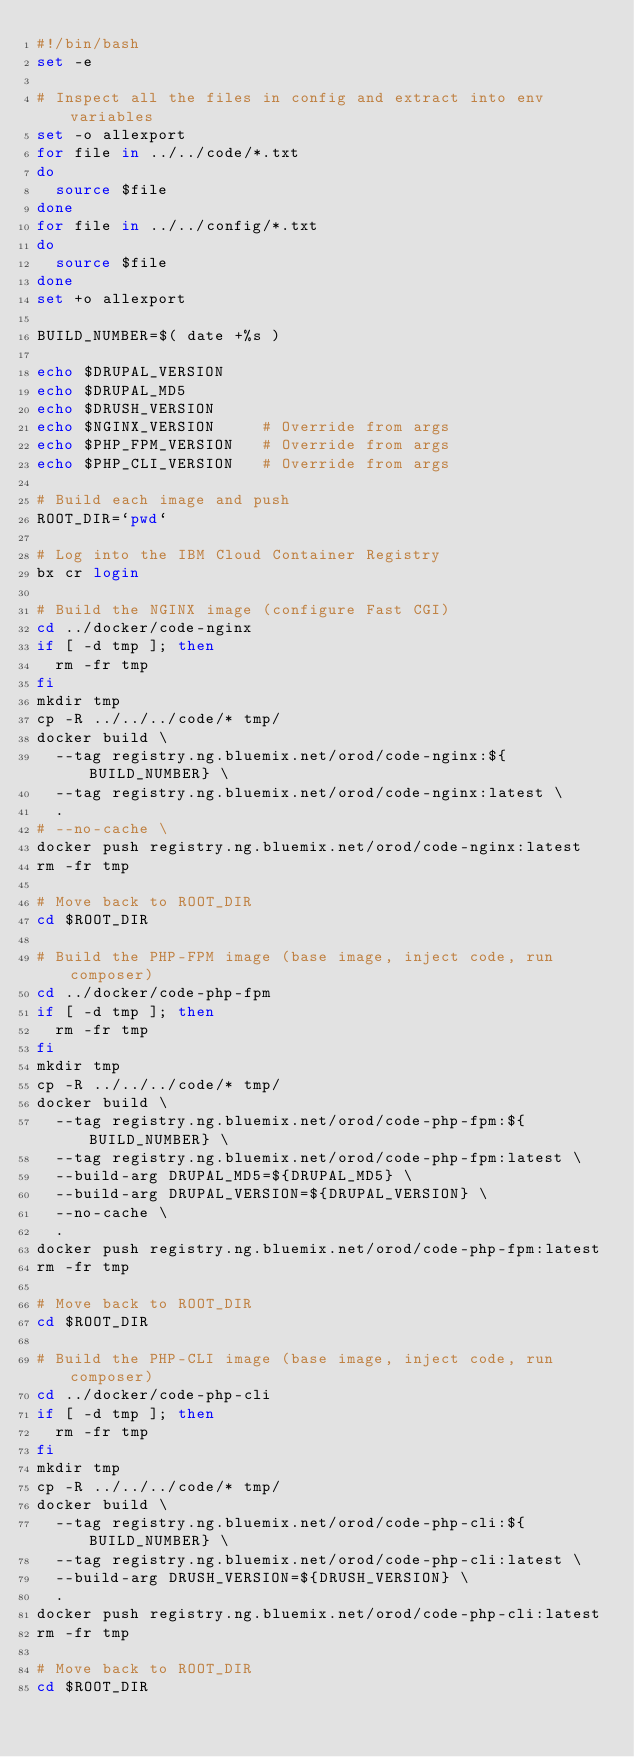Convert code to text. <code><loc_0><loc_0><loc_500><loc_500><_Bash_>#!/bin/bash
set -e

# Inspect all the files in config and extract into env variables
set -o allexport
for file in ../../code/*.txt
do
  source $file
done
for file in ../../config/*.txt
do
  source $file
done
set +o allexport

BUILD_NUMBER=$( date +%s )

echo $DRUPAL_VERSION
echo $DRUPAL_MD5
echo $DRUSH_VERSION
echo $NGINX_VERSION     # Override from args
echo $PHP_FPM_VERSION   # Override from args
echo $PHP_CLI_VERSION   # Override from args

# Build each image and push
ROOT_DIR=`pwd`

# Log into the IBM Cloud Container Registry
bx cr login

# Build the NGINX image (configure Fast CGI)
cd ../docker/code-nginx
if [ -d tmp ]; then
  rm -fr tmp
fi
mkdir tmp
cp -R ../../../code/* tmp/
docker build \
  --tag registry.ng.bluemix.net/orod/code-nginx:${BUILD_NUMBER} \
  --tag registry.ng.bluemix.net/orod/code-nginx:latest \
  .
# --no-cache \
docker push registry.ng.bluemix.net/orod/code-nginx:latest
rm -fr tmp

# Move back to ROOT_DIR
cd $ROOT_DIR

# Build the PHP-FPM image (base image, inject code, run composer)
cd ../docker/code-php-fpm
if [ -d tmp ]; then
  rm -fr tmp
fi
mkdir tmp
cp -R ../../../code/* tmp/
docker build \
  --tag registry.ng.bluemix.net/orod/code-php-fpm:${BUILD_NUMBER} \
  --tag registry.ng.bluemix.net/orod/code-php-fpm:latest \
  --build-arg DRUPAL_MD5=${DRUPAL_MD5} \
  --build-arg DRUPAL_VERSION=${DRUPAL_VERSION} \
  --no-cache \
  .
docker push registry.ng.bluemix.net/orod/code-php-fpm:latest
rm -fr tmp

# Move back to ROOT_DIR
cd $ROOT_DIR

# Build the PHP-CLI image (base image, inject code, run composer)
cd ../docker/code-php-cli
if [ -d tmp ]; then
  rm -fr tmp
fi
mkdir tmp
cp -R ../../../code/* tmp/
docker build \
  --tag registry.ng.bluemix.net/orod/code-php-cli:${BUILD_NUMBER} \
  --tag registry.ng.bluemix.net/orod/code-php-cli:latest \
  --build-arg DRUSH_VERSION=${DRUSH_VERSION} \
  .
docker push registry.ng.bluemix.net/orod/code-php-cli:latest
rm -fr tmp

# Move back to ROOT_DIR
cd $ROOT_DIR
</code> 